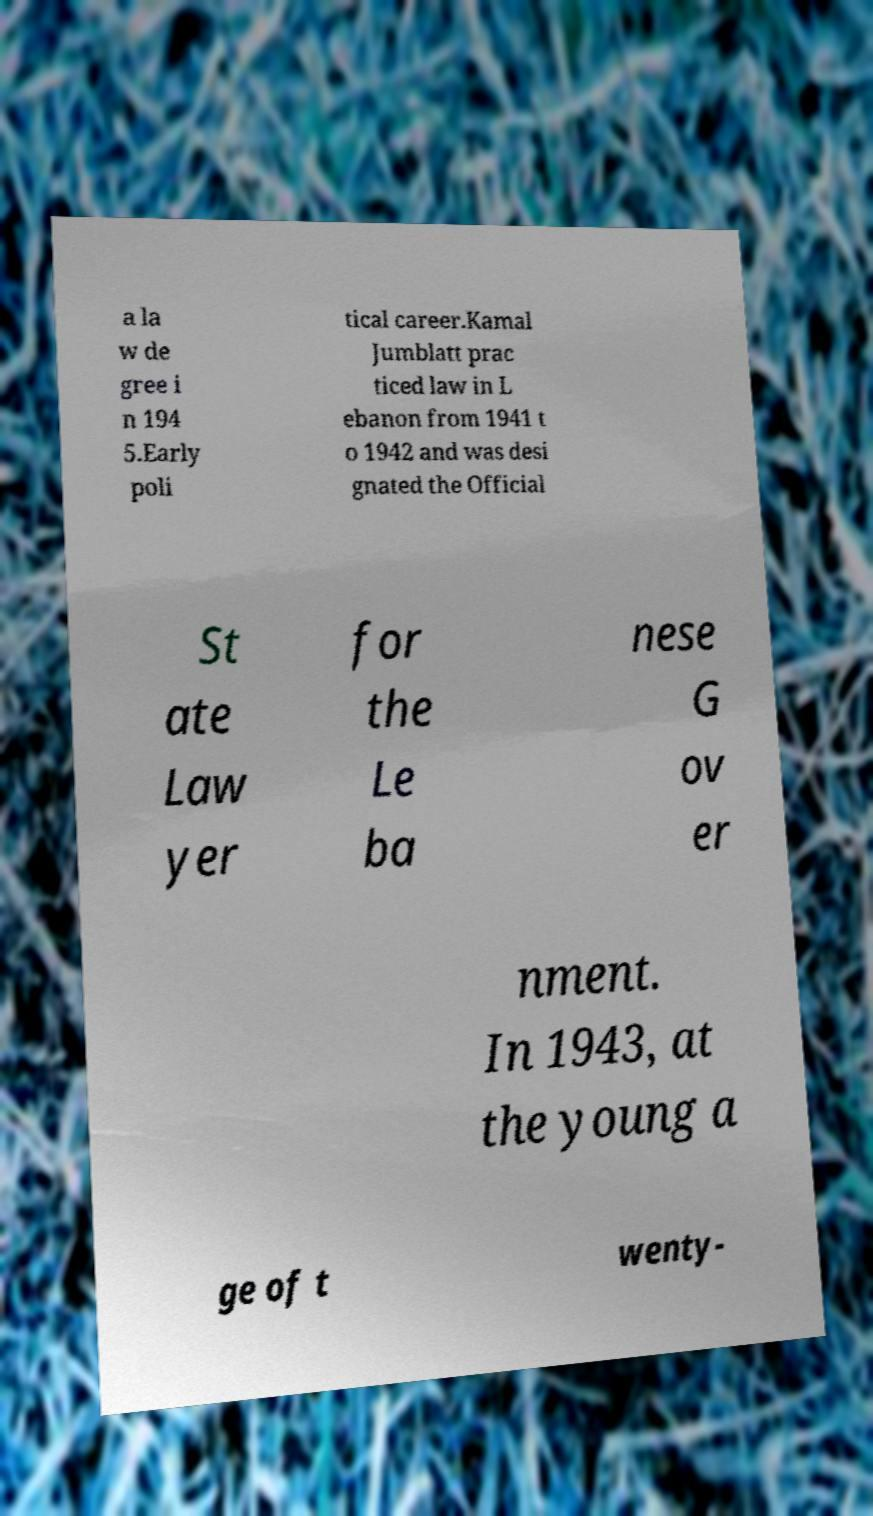Please read and relay the text visible in this image. What does it say? a la w de gree i n 194 5.Early poli tical career.Kamal Jumblatt prac ticed law in L ebanon from 1941 t o 1942 and was desi gnated the Official St ate Law yer for the Le ba nese G ov er nment. In 1943, at the young a ge of t wenty- 